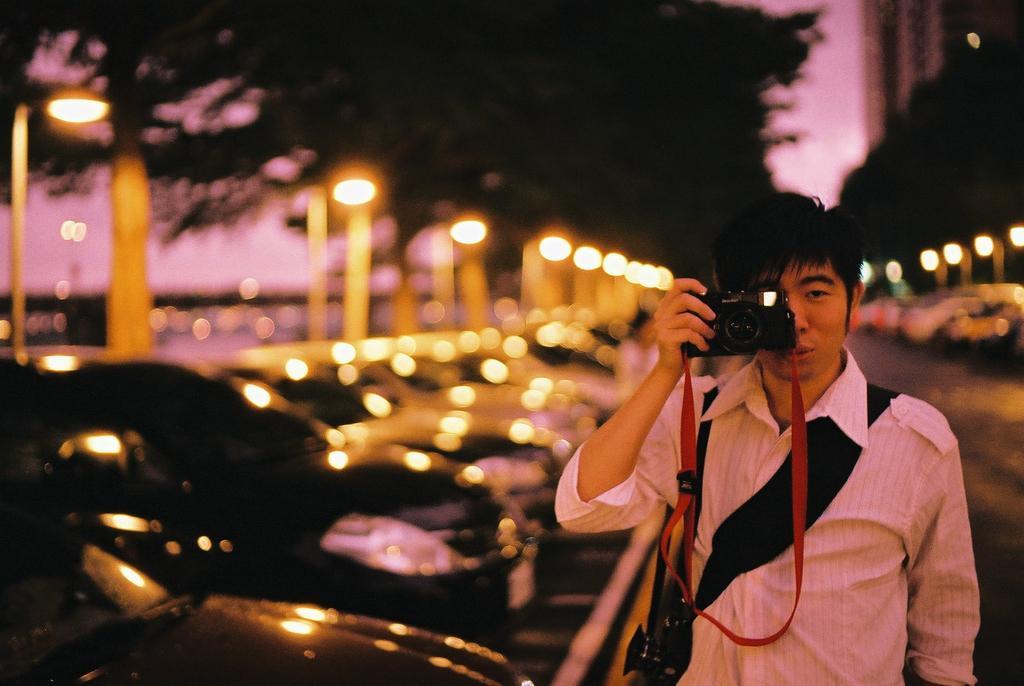Can you describe this image briefly? In this picture we can see man holding camera in one hand and taking picture and beside to him we can see cars parked and in background we can see trees, light and it is blur. 